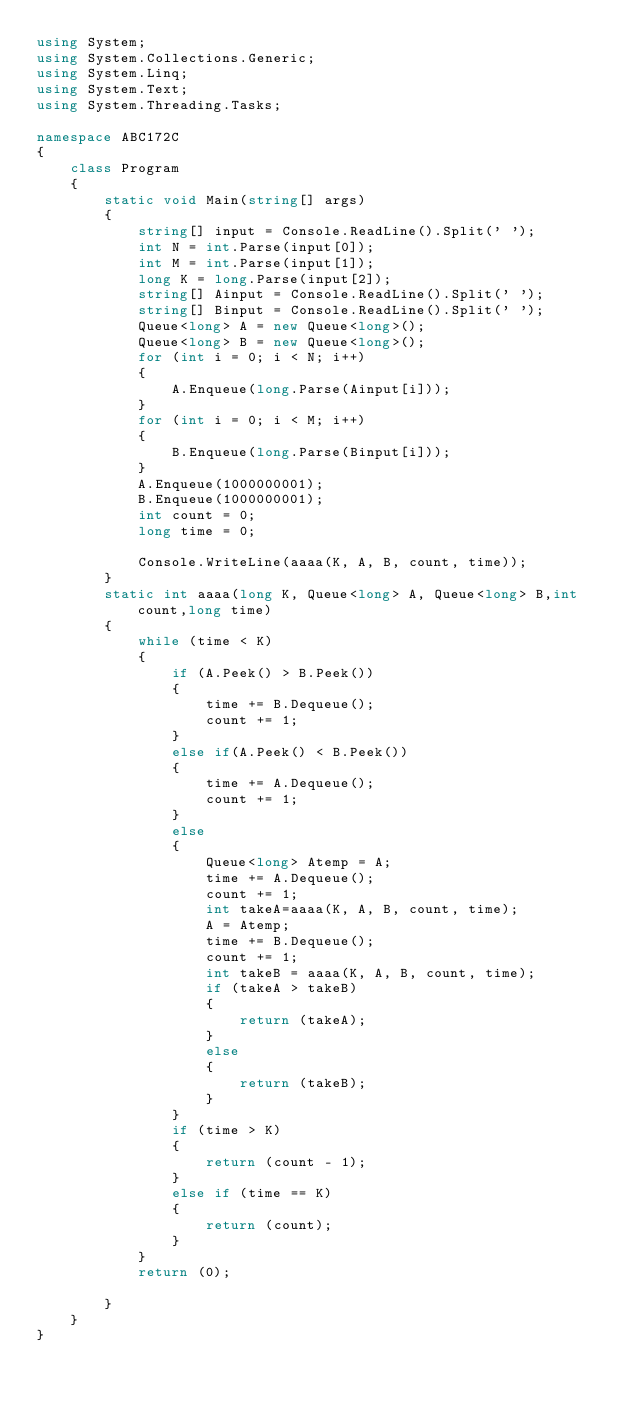<code> <loc_0><loc_0><loc_500><loc_500><_C#_>using System;
using System.Collections.Generic;
using System.Linq;
using System.Text;
using System.Threading.Tasks;

namespace ABC172C
{
    class Program
    {
        static void Main(string[] args)
        {
            string[] input = Console.ReadLine().Split(' ');
            int N = int.Parse(input[0]);
            int M = int.Parse(input[1]);
            long K = long.Parse(input[2]);
            string[] Ainput = Console.ReadLine().Split(' ');
            string[] Binput = Console.ReadLine().Split(' ');
            Queue<long> A = new Queue<long>();
            Queue<long> B = new Queue<long>();
            for (int i = 0; i < N; i++)
            {
                A.Enqueue(long.Parse(Ainput[i]));
            }
            for (int i = 0; i < M; i++)
            {
                B.Enqueue(long.Parse(Binput[i]));
            }
            A.Enqueue(1000000001);
            B.Enqueue(1000000001);
            int count = 0;
            long time = 0;
            
            Console.WriteLine(aaaa(K, A, B, count, time));
        }
        static int aaaa(long K, Queue<long> A, Queue<long> B,int count,long time)
        {
            while (time < K)
            {
                if (A.Peek() > B.Peek())
                {
                    time += B.Dequeue();
                    count += 1;
                }
                else if(A.Peek() < B.Peek())
                {
                    time += A.Dequeue();
                    count += 1;
                }
                else
                {
                    Queue<long> Atemp = A;
                    time += A.Dequeue();
                    count += 1;
                    int takeA=aaaa(K, A, B, count, time);
                    A = Atemp;
                    time += B.Dequeue();
                    count += 1;
                    int takeB = aaaa(K, A, B, count, time);
                    if (takeA > takeB)
                    {
                        return (takeA);
                    }
                    else
                    {
                        return (takeB);
                    }
                }
                if (time > K)
                {
                    return (count - 1);
                }
                else if (time == K)
                {
                    return (count);
                }
            }
            return (0);
            
        }
    }
}
</code> 